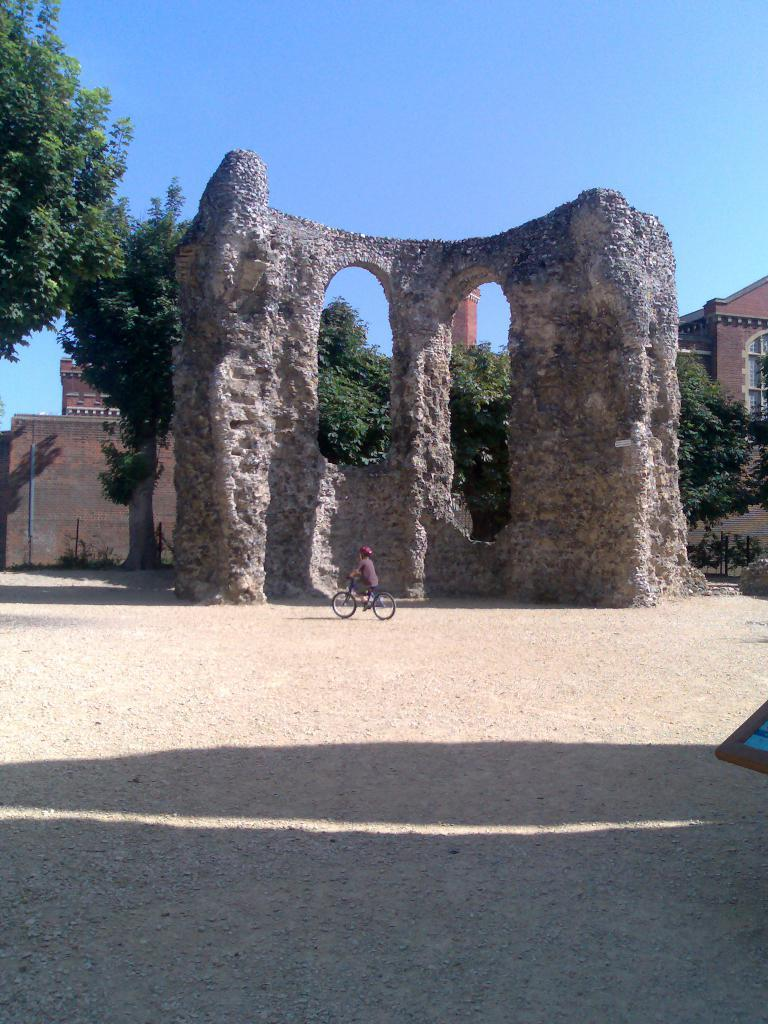What is in the foreground of the picture? There is soil in the foreground of the picture. What can be seen in the center of the picture? There are trees and a wall in the center of the picture. What is visible in the background of the picture? There is a building in the background of the picture. What is the condition of the sky in the picture? The sky is clear in the picture. What is the weather like in the image? It is sunny in the image. How many masks are being worn by the trees in the image? There are no masks present in the image, as it features trees, a wall, a building, and soil. What type of voyage is depicted in the image? There is no voyage depicted in the image; it shows a scene with trees, a wall, a building, and soil. 